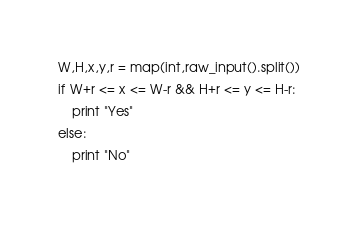<code> <loc_0><loc_0><loc_500><loc_500><_Python_>W,H,x,y,r = map(int,raw_input().split())
if W+r <= x <= W-r && H+r <= y <= H-r:
	print "Yes"
else:
	print "No"</code> 